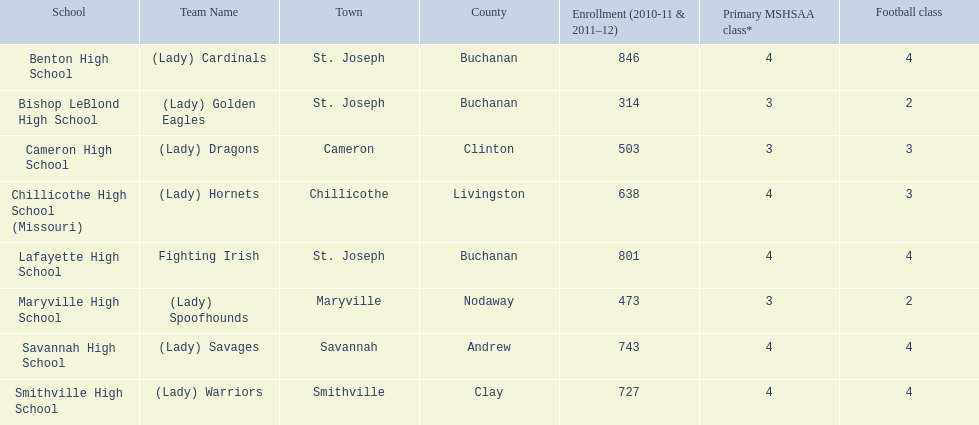At lafayette high school, what is the quantity of football classes provided? 4. 